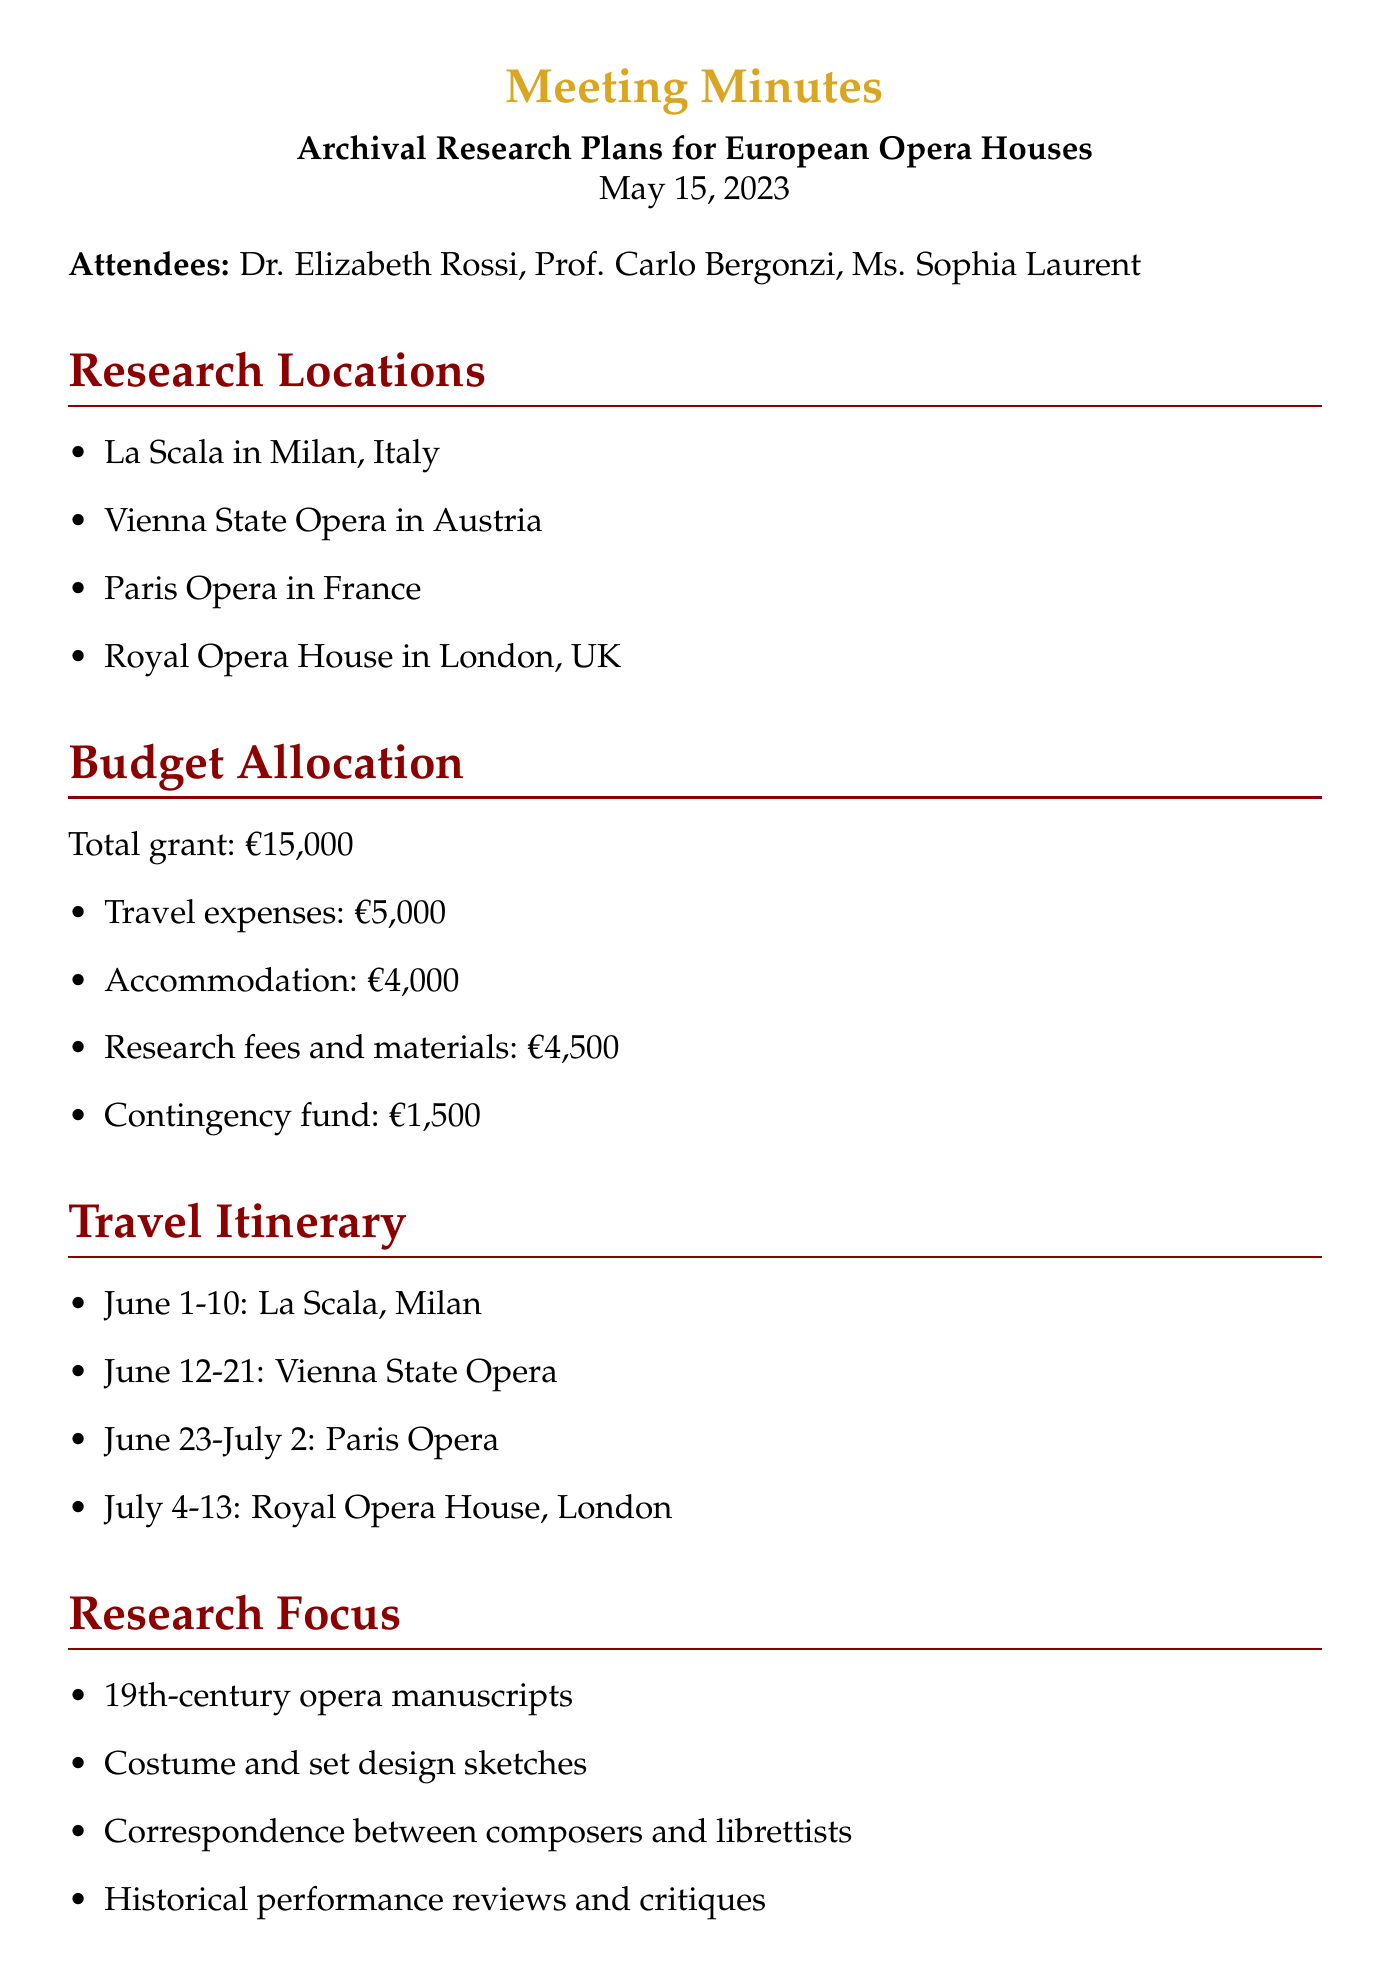What is the total grant amount? The total grant amount is stated in the budget allocation section as €15,000.
Answer: €15,000 How many days are scheduled for the visit to La Scala? The itinerary specifies the visit to La Scala will occur from June 1 to June 10, which is a total of 10 days.
Answer: 10 days Who is the contact person at the Vienna State Opera for restricted archives? The document mentions Frau Strauss as the contact for restricted archives at the Vienna State Opera.
Answer: Frau Strauss What is the budget allocated for travel expenses? The budget allocation section clearly states travel expenses as €5,000.
Answer: €5,000 What type of research documents will be focused on at the Paris Opera? The focus includes various types of documents, with historical performance reviews and critiques specifically noted for the Paris Opera.
Answer: Historical performance reviews and critiques Which month do the travel plans start? The travel itinerary begins with visits starting in June 2023.
Answer: June How many action items are listed in the document? Counting the action items in the document reveals there are three actions listed.
Answer: 3 What is the last arrangement mentioned for archival access? The last mention of an archival access arrangement is confirming an appointment with Sir Britten at the Royal Opera House.
Answer: Confirm appointment with Sir Britten 